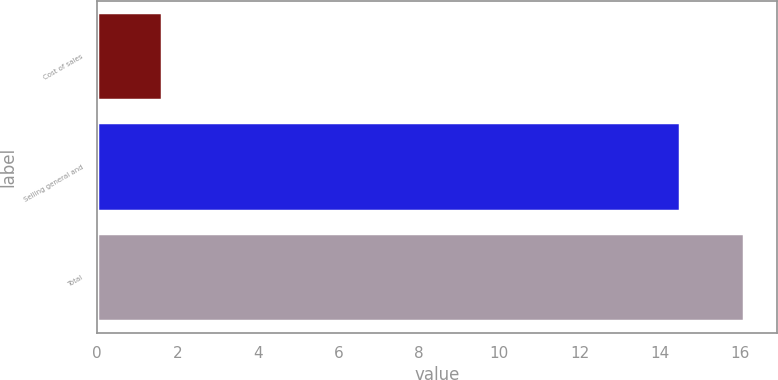Convert chart. <chart><loc_0><loc_0><loc_500><loc_500><bar_chart><fcel>Cost of sales<fcel>Selling general and<fcel>Total<nl><fcel>1.6<fcel>14.5<fcel>16.1<nl></chart> 